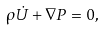<formula> <loc_0><loc_0><loc_500><loc_500>\rho \dot { U } + \nabla P = 0 ,</formula> 